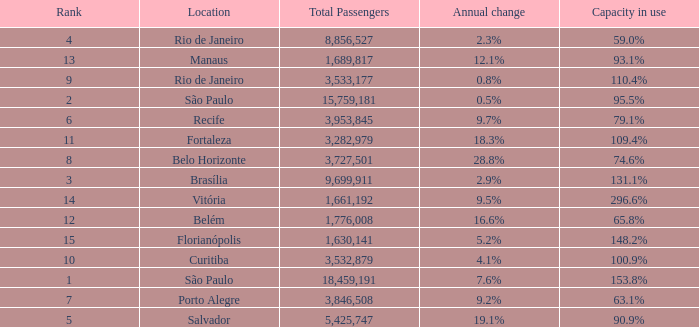What is the total number of Total Passengers when the annual change is 28.8% and the rank is less than 8? 0.0. 